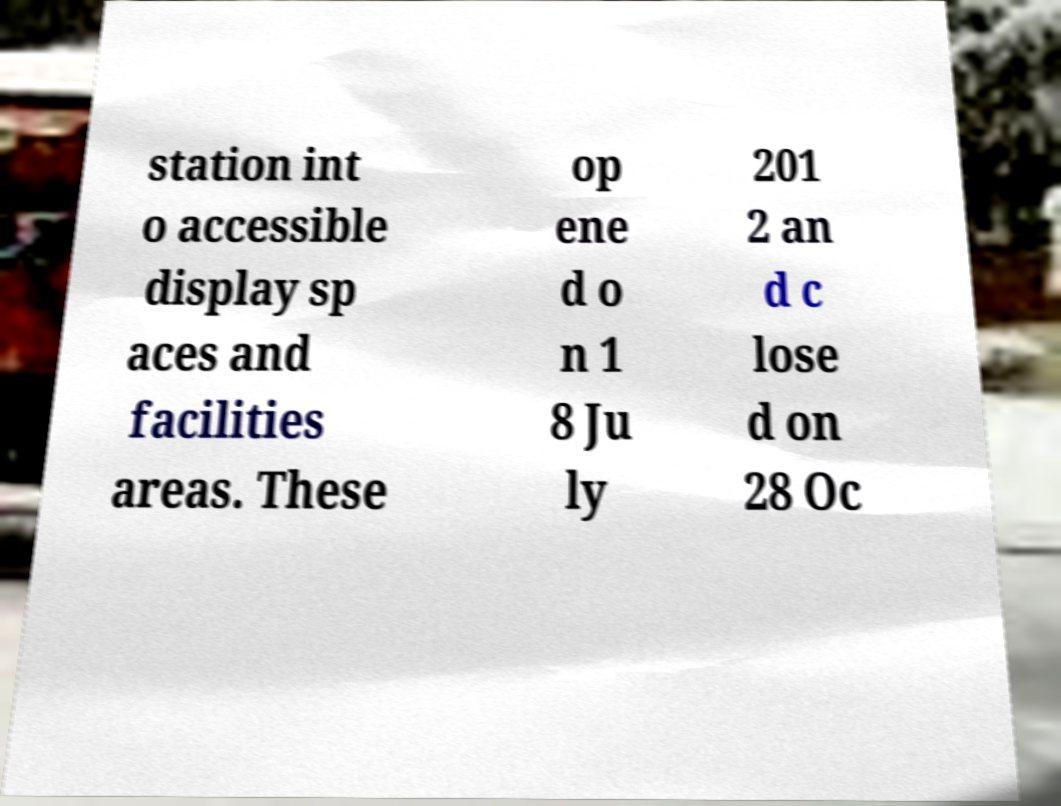Can you read and provide the text displayed in the image?This photo seems to have some interesting text. Can you extract and type it out for me? station int o accessible display sp aces and facilities areas. These op ene d o n 1 8 Ju ly 201 2 an d c lose d on 28 Oc 